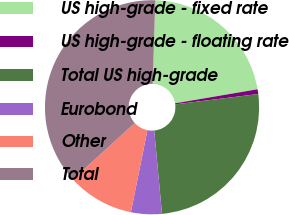<chart> <loc_0><loc_0><loc_500><loc_500><pie_chart><fcel>US high-grade - fixed rate<fcel>US high-grade - floating rate<fcel>Total US high-grade<fcel>Eurobond<fcel>Other<fcel>Total<nl><fcel>21.83%<fcel>0.71%<fcel>25.49%<fcel>4.65%<fcel>10.06%<fcel>37.26%<nl></chart> 